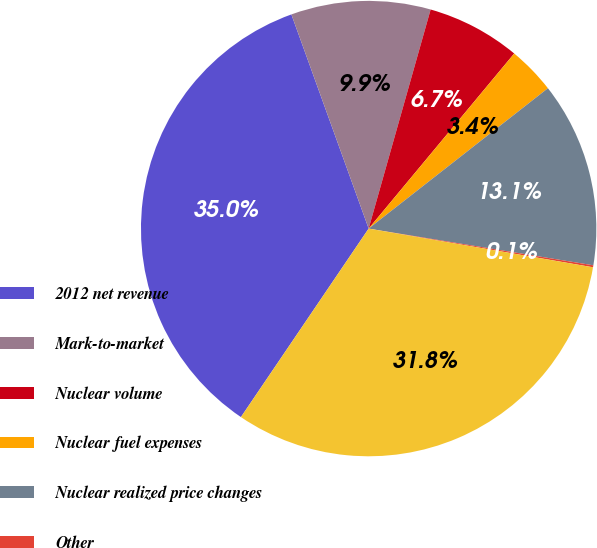Convert chart. <chart><loc_0><loc_0><loc_500><loc_500><pie_chart><fcel>2012 net revenue<fcel>Mark-to-market<fcel>Nuclear volume<fcel>Nuclear fuel expenses<fcel>Nuclear realized price changes<fcel>Other<fcel>2013 net revenue<nl><fcel>35.01%<fcel>9.9%<fcel>6.65%<fcel>3.39%<fcel>13.15%<fcel>0.14%<fcel>31.76%<nl></chart> 